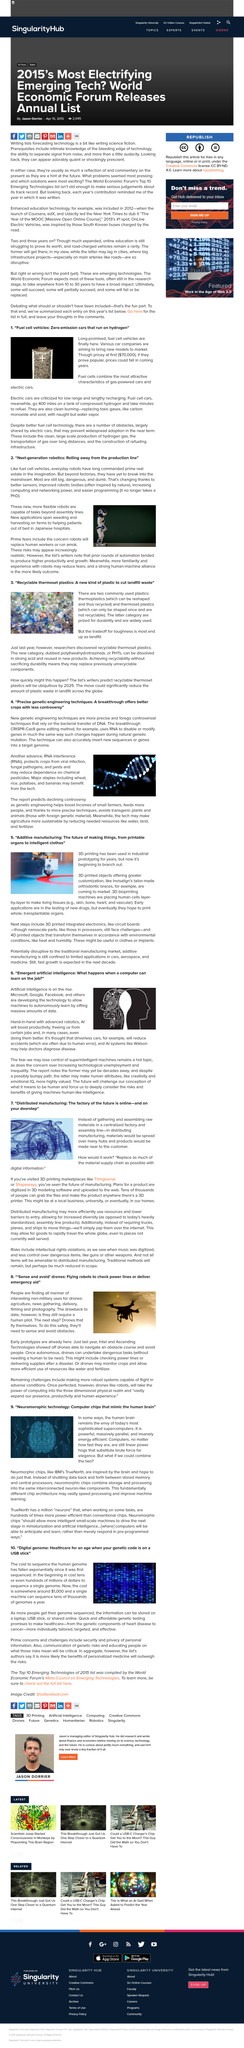Point out several critical features in this image. Japan has implemented the use of robots in hospitals to assist in getting patients out of bed. Distributed manufacturing proposes that the traditional material supply chain would need to be replaced with a digital information supply chain to achieve the benefits of decentralization, flexibility, and increased efficiency. Poly(hexahydrotriazine)s, also known as PHTs, can be reused by dissolving them in strong acid. 3D bioprinting has the capability to replicate a variety of living tissues, including skin, bone, heart, and vascular tissues. Thingiverse and Shapeways are examples of 3D printing marketplaces, which provide users with a platform to access and purchase 3D printable designs and physical products, respectively. 